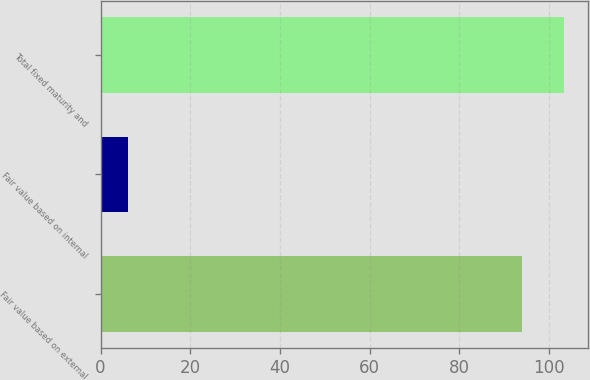<chart> <loc_0><loc_0><loc_500><loc_500><bar_chart><fcel>Fair value based on external<fcel>Fair value based on internal<fcel>Total fixed maturity and<nl><fcel>94<fcel>6<fcel>103.4<nl></chart> 